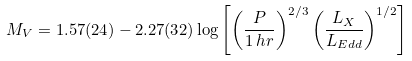Convert formula to latex. <formula><loc_0><loc_0><loc_500><loc_500>M _ { V } = 1 . 5 7 ( 2 4 ) - 2 . 2 7 ( 3 2 ) \log \left [ \left ( \frac { P } { 1 \, h r } \right ) ^ { 2 / 3 } \left ( \frac { L _ { X } } { L _ { E d d } } \right ) ^ { 1 / 2 } \right ]</formula> 